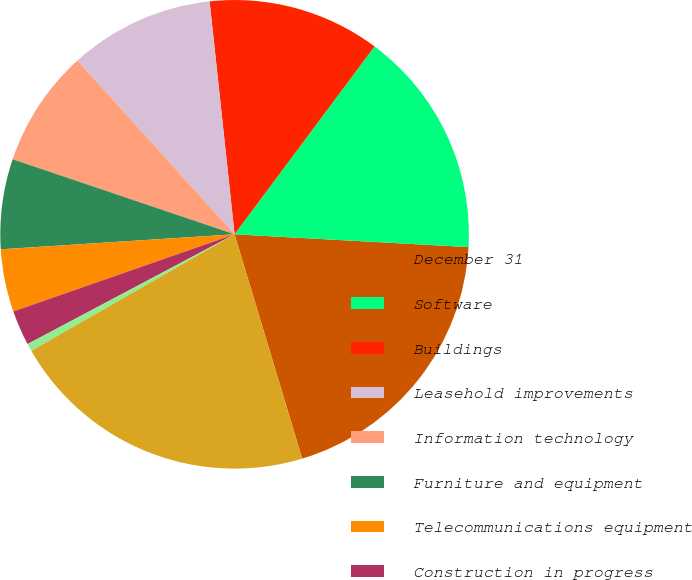<chart> <loc_0><loc_0><loc_500><loc_500><pie_chart><fcel>December 31<fcel>Software<fcel>Buildings<fcel>Leasehold improvements<fcel>Information technology<fcel>Furniture and equipment<fcel>Telecommunications equipment<fcel>Construction in progress<fcel>Land<fcel>Total equipment office<nl><fcel>19.47%<fcel>15.68%<fcel>11.89%<fcel>10.0%<fcel>8.11%<fcel>6.21%<fcel>4.32%<fcel>2.42%<fcel>0.53%<fcel>21.37%<nl></chart> 